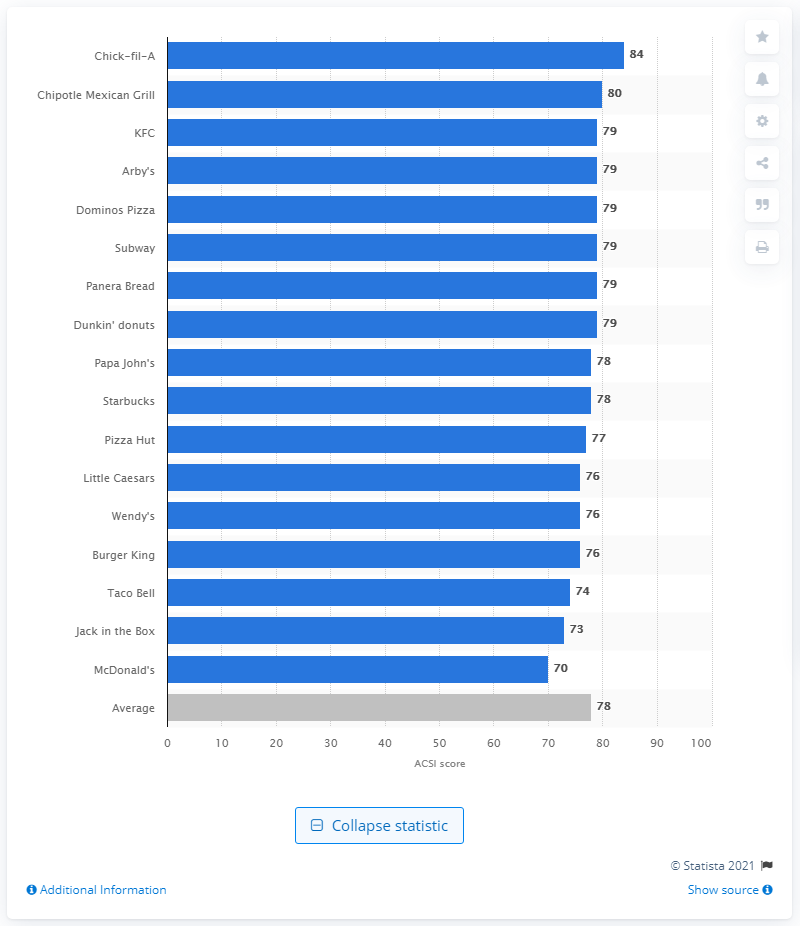Mention a couple of crucial points in this snapshot. In 2020, the ACSI score for all quick service restaurants in the U.S. was 78, indicating a generally positive customer experience. 